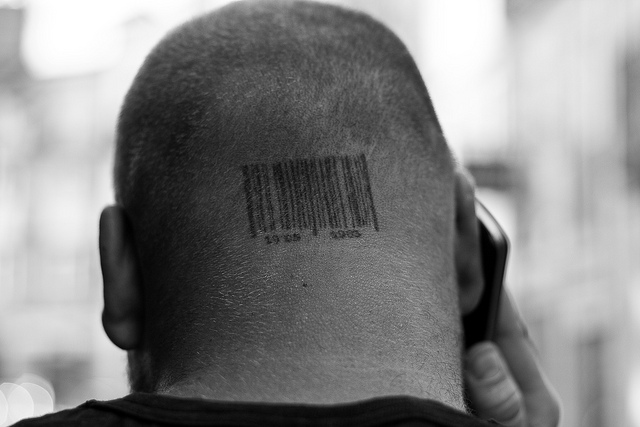Please identify all text content in this image. 1983 